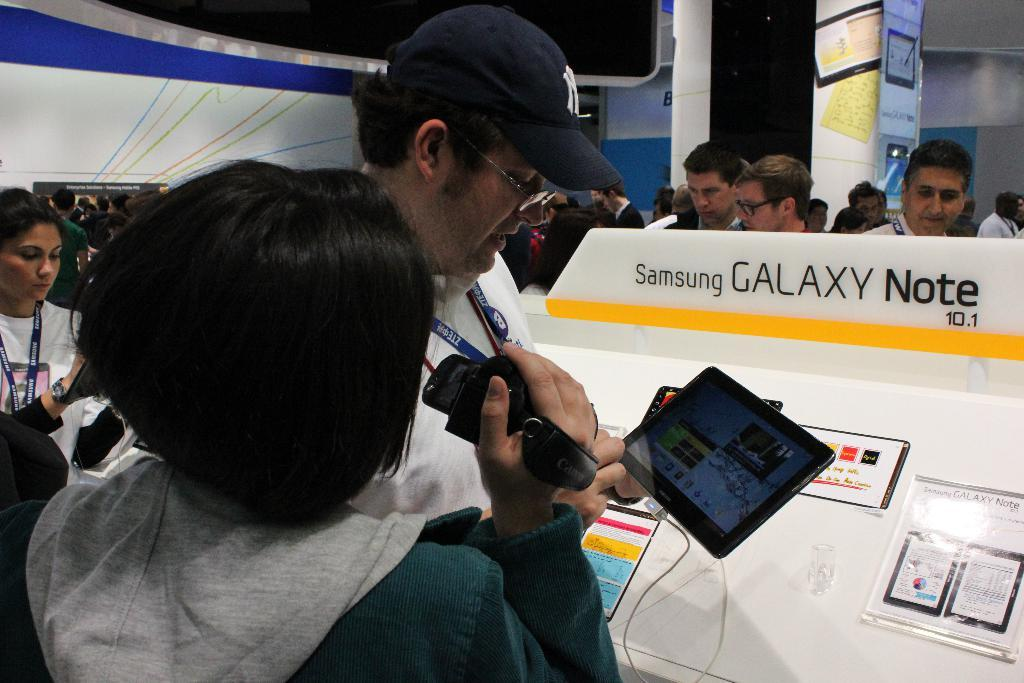What are the people in the image doing? The people in the image are standing on the floor. What objects are some of the people holding? Some of the people are holding cameras, and some are holding tablets. How many sisters are present in the image? There is no mention of sisters in the image, so we cannot determine the number of sisters present. What time of day is it in the image, based on the hour? There is no information about the time of day or the hour in the image. 